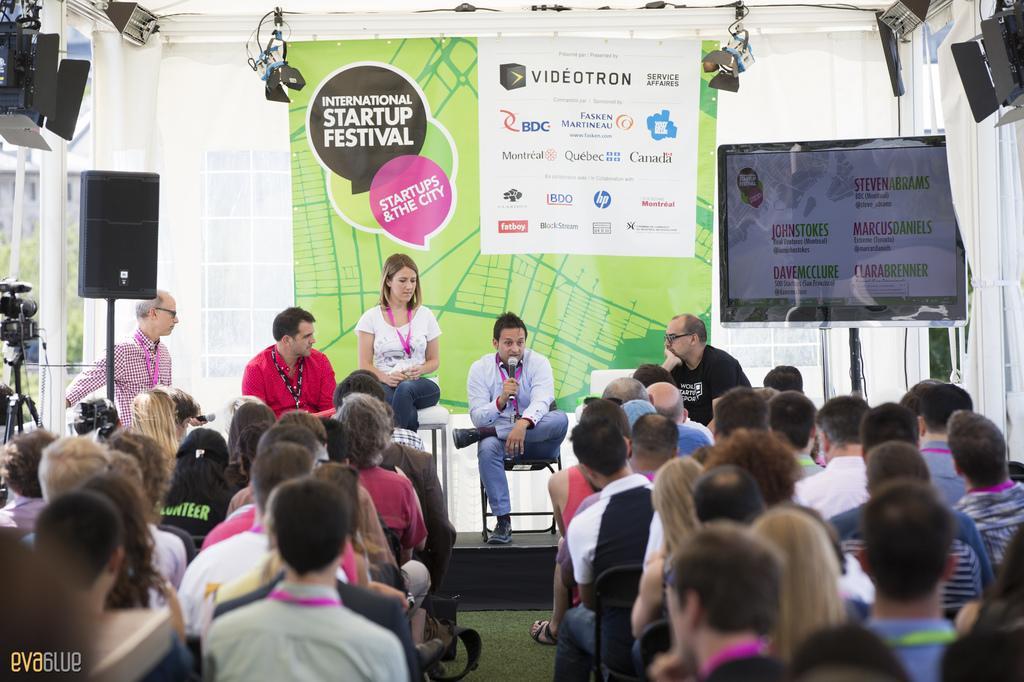Please provide a concise description of this image. In this image, we can see persons wearing clothes and sitting on chairs. There is a banner in the middle of the image. There is a screen on the right side of the image. There are lights in the top left and in the top right of the image. There is a camera and speaker on the left side of the image. 